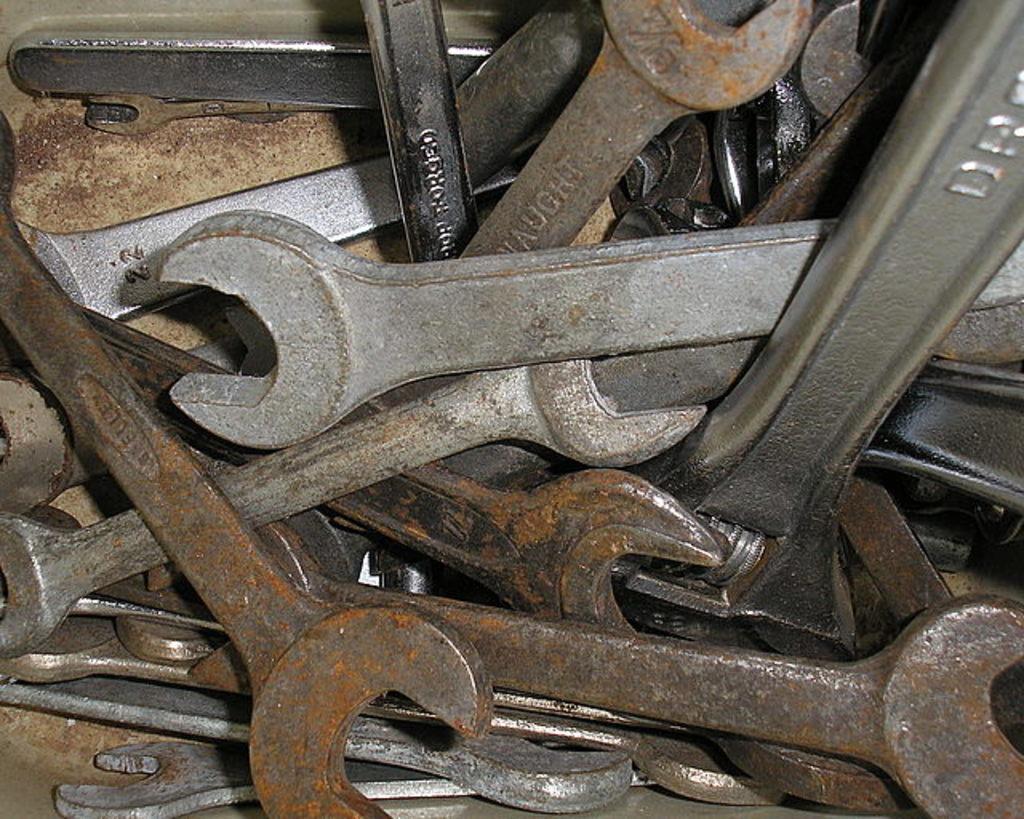Please provide a concise description of this image. In this picture there are iron tools in a box. Few tools are rusted. 